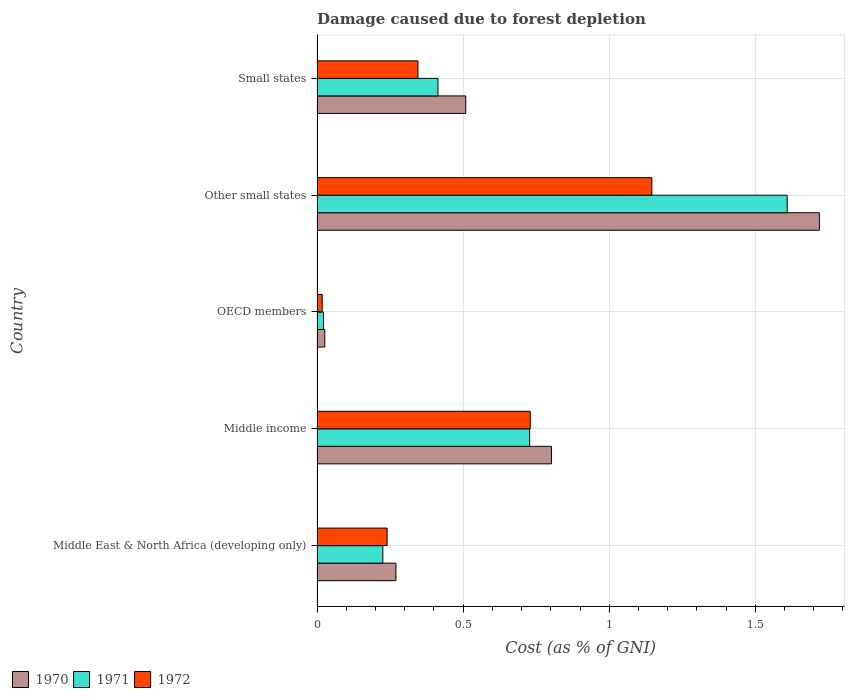How many groups of bars are there?
Keep it short and to the point. 5. Are the number of bars per tick equal to the number of legend labels?
Provide a short and direct response. Yes. How many bars are there on the 4th tick from the bottom?
Your answer should be very brief. 3. What is the label of the 2nd group of bars from the top?
Keep it short and to the point. Other small states. In how many cases, is the number of bars for a given country not equal to the number of legend labels?
Give a very brief answer. 0. What is the cost of damage caused due to forest depletion in 1971 in OECD members?
Offer a terse response. 0.02. Across all countries, what is the maximum cost of damage caused due to forest depletion in 1970?
Keep it short and to the point. 1.72. Across all countries, what is the minimum cost of damage caused due to forest depletion in 1971?
Ensure brevity in your answer.  0.02. In which country was the cost of damage caused due to forest depletion in 1970 maximum?
Provide a short and direct response. Other small states. What is the total cost of damage caused due to forest depletion in 1970 in the graph?
Provide a short and direct response. 3.33. What is the difference between the cost of damage caused due to forest depletion in 1970 in Middle East & North Africa (developing only) and that in Small states?
Your response must be concise. -0.24. What is the difference between the cost of damage caused due to forest depletion in 1970 in Middle income and the cost of damage caused due to forest depletion in 1972 in Small states?
Keep it short and to the point. 0.46. What is the average cost of damage caused due to forest depletion in 1971 per country?
Keep it short and to the point. 0.6. What is the difference between the cost of damage caused due to forest depletion in 1970 and cost of damage caused due to forest depletion in 1972 in Middle income?
Provide a short and direct response. 0.07. In how many countries, is the cost of damage caused due to forest depletion in 1970 greater than 0.9 %?
Keep it short and to the point. 1. What is the ratio of the cost of damage caused due to forest depletion in 1970 in Middle East & North Africa (developing only) to that in Middle income?
Make the answer very short. 0.34. What is the difference between the highest and the second highest cost of damage caused due to forest depletion in 1971?
Your response must be concise. 0.88. What is the difference between the highest and the lowest cost of damage caused due to forest depletion in 1972?
Your answer should be compact. 1.13. What does the 2nd bar from the bottom in Other small states represents?
Give a very brief answer. 1971. Is it the case that in every country, the sum of the cost of damage caused due to forest depletion in 1970 and cost of damage caused due to forest depletion in 1972 is greater than the cost of damage caused due to forest depletion in 1971?
Offer a terse response. Yes. How many countries are there in the graph?
Give a very brief answer. 5. Does the graph contain grids?
Give a very brief answer. Yes. Where does the legend appear in the graph?
Your answer should be compact. Bottom left. How are the legend labels stacked?
Offer a very short reply. Horizontal. What is the title of the graph?
Provide a short and direct response. Damage caused due to forest depletion. What is the label or title of the X-axis?
Make the answer very short. Cost (as % of GNI). What is the label or title of the Y-axis?
Provide a succinct answer. Country. What is the Cost (as % of GNI) in 1970 in Middle East & North Africa (developing only)?
Offer a very short reply. 0.27. What is the Cost (as % of GNI) of 1971 in Middle East & North Africa (developing only)?
Ensure brevity in your answer.  0.23. What is the Cost (as % of GNI) of 1972 in Middle East & North Africa (developing only)?
Your answer should be very brief. 0.24. What is the Cost (as % of GNI) of 1970 in Middle income?
Your answer should be compact. 0.8. What is the Cost (as % of GNI) in 1971 in Middle income?
Provide a short and direct response. 0.73. What is the Cost (as % of GNI) of 1972 in Middle income?
Your answer should be compact. 0.73. What is the Cost (as % of GNI) of 1970 in OECD members?
Give a very brief answer. 0.03. What is the Cost (as % of GNI) of 1971 in OECD members?
Offer a terse response. 0.02. What is the Cost (as % of GNI) of 1972 in OECD members?
Offer a very short reply. 0.02. What is the Cost (as % of GNI) in 1970 in Other small states?
Offer a very short reply. 1.72. What is the Cost (as % of GNI) in 1971 in Other small states?
Make the answer very short. 1.61. What is the Cost (as % of GNI) of 1972 in Other small states?
Your answer should be very brief. 1.15. What is the Cost (as % of GNI) of 1970 in Small states?
Your answer should be very brief. 0.51. What is the Cost (as % of GNI) in 1971 in Small states?
Keep it short and to the point. 0.41. What is the Cost (as % of GNI) of 1972 in Small states?
Ensure brevity in your answer.  0.35. Across all countries, what is the maximum Cost (as % of GNI) in 1970?
Provide a succinct answer. 1.72. Across all countries, what is the maximum Cost (as % of GNI) of 1971?
Give a very brief answer. 1.61. Across all countries, what is the maximum Cost (as % of GNI) of 1972?
Your response must be concise. 1.15. Across all countries, what is the minimum Cost (as % of GNI) in 1970?
Keep it short and to the point. 0.03. Across all countries, what is the minimum Cost (as % of GNI) of 1971?
Make the answer very short. 0.02. Across all countries, what is the minimum Cost (as % of GNI) in 1972?
Your answer should be compact. 0.02. What is the total Cost (as % of GNI) of 1970 in the graph?
Give a very brief answer. 3.33. What is the total Cost (as % of GNI) of 1971 in the graph?
Your answer should be compact. 3. What is the total Cost (as % of GNI) in 1972 in the graph?
Offer a very short reply. 2.48. What is the difference between the Cost (as % of GNI) in 1970 in Middle East & North Africa (developing only) and that in Middle income?
Your answer should be very brief. -0.53. What is the difference between the Cost (as % of GNI) in 1971 in Middle East & North Africa (developing only) and that in Middle income?
Ensure brevity in your answer.  -0.5. What is the difference between the Cost (as % of GNI) in 1972 in Middle East & North Africa (developing only) and that in Middle income?
Provide a short and direct response. -0.49. What is the difference between the Cost (as % of GNI) in 1970 in Middle East & North Africa (developing only) and that in OECD members?
Offer a very short reply. 0.24. What is the difference between the Cost (as % of GNI) in 1971 in Middle East & North Africa (developing only) and that in OECD members?
Ensure brevity in your answer.  0.2. What is the difference between the Cost (as % of GNI) of 1972 in Middle East & North Africa (developing only) and that in OECD members?
Offer a terse response. 0.22. What is the difference between the Cost (as % of GNI) in 1970 in Middle East & North Africa (developing only) and that in Other small states?
Ensure brevity in your answer.  -1.45. What is the difference between the Cost (as % of GNI) in 1971 in Middle East & North Africa (developing only) and that in Other small states?
Your answer should be compact. -1.38. What is the difference between the Cost (as % of GNI) of 1972 in Middle East & North Africa (developing only) and that in Other small states?
Your response must be concise. -0.91. What is the difference between the Cost (as % of GNI) of 1970 in Middle East & North Africa (developing only) and that in Small states?
Make the answer very short. -0.24. What is the difference between the Cost (as % of GNI) of 1971 in Middle East & North Africa (developing only) and that in Small states?
Your response must be concise. -0.19. What is the difference between the Cost (as % of GNI) of 1972 in Middle East & North Africa (developing only) and that in Small states?
Your answer should be compact. -0.11. What is the difference between the Cost (as % of GNI) of 1970 in Middle income and that in OECD members?
Offer a very short reply. 0.78. What is the difference between the Cost (as % of GNI) in 1971 in Middle income and that in OECD members?
Provide a succinct answer. 0.71. What is the difference between the Cost (as % of GNI) in 1972 in Middle income and that in OECD members?
Keep it short and to the point. 0.71. What is the difference between the Cost (as % of GNI) of 1970 in Middle income and that in Other small states?
Make the answer very short. -0.92. What is the difference between the Cost (as % of GNI) of 1971 in Middle income and that in Other small states?
Give a very brief answer. -0.88. What is the difference between the Cost (as % of GNI) in 1972 in Middle income and that in Other small states?
Your answer should be compact. -0.42. What is the difference between the Cost (as % of GNI) of 1970 in Middle income and that in Small states?
Keep it short and to the point. 0.29. What is the difference between the Cost (as % of GNI) in 1971 in Middle income and that in Small states?
Your answer should be compact. 0.31. What is the difference between the Cost (as % of GNI) in 1972 in Middle income and that in Small states?
Offer a terse response. 0.38. What is the difference between the Cost (as % of GNI) of 1970 in OECD members and that in Other small states?
Your response must be concise. -1.69. What is the difference between the Cost (as % of GNI) in 1971 in OECD members and that in Other small states?
Offer a very short reply. -1.59. What is the difference between the Cost (as % of GNI) of 1972 in OECD members and that in Other small states?
Ensure brevity in your answer.  -1.13. What is the difference between the Cost (as % of GNI) in 1970 in OECD members and that in Small states?
Offer a terse response. -0.48. What is the difference between the Cost (as % of GNI) of 1971 in OECD members and that in Small states?
Provide a succinct answer. -0.39. What is the difference between the Cost (as % of GNI) of 1972 in OECD members and that in Small states?
Offer a very short reply. -0.33. What is the difference between the Cost (as % of GNI) of 1970 in Other small states and that in Small states?
Ensure brevity in your answer.  1.21. What is the difference between the Cost (as % of GNI) of 1971 in Other small states and that in Small states?
Your response must be concise. 1.2. What is the difference between the Cost (as % of GNI) of 1972 in Other small states and that in Small states?
Your response must be concise. 0.8. What is the difference between the Cost (as % of GNI) of 1970 in Middle East & North Africa (developing only) and the Cost (as % of GNI) of 1971 in Middle income?
Keep it short and to the point. -0.46. What is the difference between the Cost (as % of GNI) of 1970 in Middle East & North Africa (developing only) and the Cost (as % of GNI) of 1972 in Middle income?
Give a very brief answer. -0.46. What is the difference between the Cost (as % of GNI) in 1971 in Middle East & North Africa (developing only) and the Cost (as % of GNI) in 1972 in Middle income?
Your response must be concise. -0.5. What is the difference between the Cost (as % of GNI) in 1970 in Middle East & North Africa (developing only) and the Cost (as % of GNI) in 1971 in OECD members?
Ensure brevity in your answer.  0.25. What is the difference between the Cost (as % of GNI) in 1970 in Middle East & North Africa (developing only) and the Cost (as % of GNI) in 1972 in OECD members?
Provide a succinct answer. 0.25. What is the difference between the Cost (as % of GNI) in 1971 in Middle East & North Africa (developing only) and the Cost (as % of GNI) in 1972 in OECD members?
Ensure brevity in your answer.  0.21. What is the difference between the Cost (as % of GNI) in 1970 in Middle East & North Africa (developing only) and the Cost (as % of GNI) in 1971 in Other small states?
Ensure brevity in your answer.  -1.34. What is the difference between the Cost (as % of GNI) of 1970 in Middle East & North Africa (developing only) and the Cost (as % of GNI) of 1972 in Other small states?
Your answer should be very brief. -0.88. What is the difference between the Cost (as % of GNI) in 1971 in Middle East & North Africa (developing only) and the Cost (as % of GNI) in 1972 in Other small states?
Provide a succinct answer. -0.92. What is the difference between the Cost (as % of GNI) of 1970 in Middle East & North Africa (developing only) and the Cost (as % of GNI) of 1971 in Small states?
Your answer should be compact. -0.14. What is the difference between the Cost (as % of GNI) of 1970 in Middle East & North Africa (developing only) and the Cost (as % of GNI) of 1972 in Small states?
Provide a succinct answer. -0.08. What is the difference between the Cost (as % of GNI) of 1971 in Middle East & North Africa (developing only) and the Cost (as % of GNI) of 1972 in Small states?
Offer a terse response. -0.12. What is the difference between the Cost (as % of GNI) of 1970 in Middle income and the Cost (as % of GNI) of 1971 in OECD members?
Offer a terse response. 0.78. What is the difference between the Cost (as % of GNI) in 1970 in Middle income and the Cost (as % of GNI) in 1972 in OECD members?
Ensure brevity in your answer.  0.78. What is the difference between the Cost (as % of GNI) of 1971 in Middle income and the Cost (as % of GNI) of 1972 in OECD members?
Make the answer very short. 0.71. What is the difference between the Cost (as % of GNI) of 1970 in Middle income and the Cost (as % of GNI) of 1971 in Other small states?
Offer a very short reply. -0.81. What is the difference between the Cost (as % of GNI) of 1970 in Middle income and the Cost (as % of GNI) of 1972 in Other small states?
Your answer should be very brief. -0.34. What is the difference between the Cost (as % of GNI) in 1971 in Middle income and the Cost (as % of GNI) in 1972 in Other small states?
Offer a very short reply. -0.42. What is the difference between the Cost (as % of GNI) of 1970 in Middle income and the Cost (as % of GNI) of 1971 in Small states?
Keep it short and to the point. 0.39. What is the difference between the Cost (as % of GNI) of 1970 in Middle income and the Cost (as % of GNI) of 1972 in Small states?
Keep it short and to the point. 0.46. What is the difference between the Cost (as % of GNI) of 1971 in Middle income and the Cost (as % of GNI) of 1972 in Small states?
Provide a short and direct response. 0.38. What is the difference between the Cost (as % of GNI) of 1970 in OECD members and the Cost (as % of GNI) of 1971 in Other small states?
Give a very brief answer. -1.58. What is the difference between the Cost (as % of GNI) of 1970 in OECD members and the Cost (as % of GNI) of 1972 in Other small states?
Give a very brief answer. -1.12. What is the difference between the Cost (as % of GNI) in 1971 in OECD members and the Cost (as % of GNI) in 1972 in Other small states?
Make the answer very short. -1.12. What is the difference between the Cost (as % of GNI) of 1970 in OECD members and the Cost (as % of GNI) of 1971 in Small states?
Provide a succinct answer. -0.39. What is the difference between the Cost (as % of GNI) in 1970 in OECD members and the Cost (as % of GNI) in 1972 in Small states?
Your answer should be compact. -0.32. What is the difference between the Cost (as % of GNI) in 1971 in OECD members and the Cost (as % of GNI) in 1972 in Small states?
Your response must be concise. -0.32. What is the difference between the Cost (as % of GNI) in 1970 in Other small states and the Cost (as % of GNI) in 1971 in Small states?
Give a very brief answer. 1.31. What is the difference between the Cost (as % of GNI) in 1970 in Other small states and the Cost (as % of GNI) in 1972 in Small states?
Your answer should be compact. 1.37. What is the difference between the Cost (as % of GNI) in 1971 in Other small states and the Cost (as % of GNI) in 1972 in Small states?
Make the answer very short. 1.26. What is the average Cost (as % of GNI) in 1970 per country?
Give a very brief answer. 0.67. What is the average Cost (as % of GNI) of 1971 per country?
Make the answer very short. 0.6. What is the average Cost (as % of GNI) in 1972 per country?
Your answer should be compact. 0.5. What is the difference between the Cost (as % of GNI) in 1970 and Cost (as % of GNI) in 1971 in Middle East & North Africa (developing only)?
Offer a very short reply. 0.04. What is the difference between the Cost (as % of GNI) of 1970 and Cost (as % of GNI) of 1972 in Middle East & North Africa (developing only)?
Keep it short and to the point. 0.03. What is the difference between the Cost (as % of GNI) of 1971 and Cost (as % of GNI) of 1972 in Middle East & North Africa (developing only)?
Provide a short and direct response. -0.01. What is the difference between the Cost (as % of GNI) in 1970 and Cost (as % of GNI) in 1971 in Middle income?
Your answer should be compact. 0.07. What is the difference between the Cost (as % of GNI) of 1970 and Cost (as % of GNI) of 1972 in Middle income?
Make the answer very short. 0.07. What is the difference between the Cost (as % of GNI) in 1971 and Cost (as % of GNI) in 1972 in Middle income?
Provide a short and direct response. -0. What is the difference between the Cost (as % of GNI) in 1970 and Cost (as % of GNI) in 1971 in OECD members?
Your answer should be very brief. 0. What is the difference between the Cost (as % of GNI) of 1970 and Cost (as % of GNI) of 1972 in OECD members?
Provide a succinct answer. 0.01. What is the difference between the Cost (as % of GNI) of 1971 and Cost (as % of GNI) of 1972 in OECD members?
Keep it short and to the point. 0. What is the difference between the Cost (as % of GNI) in 1970 and Cost (as % of GNI) in 1971 in Other small states?
Ensure brevity in your answer.  0.11. What is the difference between the Cost (as % of GNI) of 1970 and Cost (as % of GNI) of 1972 in Other small states?
Provide a short and direct response. 0.57. What is the difference between the Cost (as % of GNI) of 1971 and Cost (as % of GNI) of 1972 in Other small states?
Give a very brief answer. 0.46. What is the difference between the Cost (as % of GNI) in 1970 and Cost (as % of GNI) in 1971 in Small states?
Your response must be concise. 0.1. What is the difference between the Cost (as % of GNI) of 1970 and Cost (as % of GNI) of 1972 in Small states?
Offer a very short reply. 0.16. What is the difference between the Cost (as % of GNI) of 1971 and Cost (as % of GNI) of 1972 in Small states?
Your answer should be compact. 0.07. What is the ratio of the Cost (as % of GNI) in 1970 in Middle East & North Africa (developing only) to that in Middle income?
Provide a short and direct response. 0.34. What is the ratio of the Cost (as % of GNI) in 1971 in Middle East & North Africa (developing only) to that in Middle income?
Keep it short and to the point. 0.31. What is the ratio of the Cost (as % of GNI) in 1972 in Middle East & North Africa (developing only) to that in Middle income?
Your response must be concise. 0.33. What is the ratio of the Cost (as % of GNI) in 1970 in Middle East & North Africa (developing only) to that in OECD members?
Provide a succinct answer. 10.19. What is the ratio of the Cost (as % of GNI) of 1971 in Middle East & North Africa (developing only) to that in OECD members?
Ensure brevity in your answer.  10.12. What is the ratio of the Cost (as % of GNI) of 1972 in Middle East & North Africa (developing only) to that in OECD members?
Give a very brief answer. 13.63. What is the ratio of the Cost (as % of GNI) in 1970 in Middle East & North Africa (developing only) to that in Other small states?
Keep it short and to the point. 0.16. What is the ratio of the Cost (as % of GNI) in 1971 in Middle East & North Africa (developing only) to that in Other small states?
Provide a succinct answer. 0.14. What is the ratio of the Cost (as % of GNI) in 1972 in Middle East & North Africa (developing only) to that in Other small states?
Provide a succinct answer. 0.21. What is the ratio of the Cost (as % of GNI) in 1970 in Middle East & North Africa (developing only) to that in Small states?
Provide a succinct answer. 0.53. What is the ratio of the Cost (as % of GNI) in 1971 in Middle East & North Africa (developing only) to that in Small states?
Provide a succinct answer. 0.54. What is the ratio of the Cost (as % of GNI) of 1972 in Middle East & North Africa (developing only) to that in Small states?
Offer a very short reply. 0.69. What is the ratio of the Cost (as % of GNI) of 1970 in Middle income to that in OECD members?
Your answer should be very brief. 30.28. What is the ratio of the Cost (as % of GNI) in 1971 in Middle income to that in OECD members?
Your answer should be compact. 32.71. What is the ratio of the Cost (as % of GNI) of 1972 in Middle income to that in OECD members?
Your answer should be very brief. 41.48. What is the ratio of the Cost (as % of GNI) in 1970 in Middle income to that in Other small states?
Keep it short and to the point. 0.47. What is the ratio of the Cost (as % of GNI) in 1971 in Middle income to that in Other small states?
Provide a short and direct response. 0.45. What is the ratio of the Cost (as % of GNI) of 1972 in Middle income to that in Other small states?
Ensure brevity in your answer.  0.64. What is the ratio of the Cost (as % of GNI) in 1970 in Middle income to that in Small states?
Ensure brevity in your answer.  1.58. What is the ratio of the Cost (as % of GNI) in 1971 in Middle income to that in Small states?
Give a very brief answer. 1.76. What is the ratio of the Cost (as % of GNI) in 1972 in Middle income to that in Small states?
Provide a short and direct response. 2.11. What is the ratio of the Cost (as % of GNI) of 1970 in OECD members to that in Other small states?
Your answer should be very brief. 0.02. What is the ratio of the Cost (as % of GNI) of 1971 in OECD members to that in Other small states?
Provide a succinct answer. 0.01. What is the ratio of the Cost (as % of GNI) of 1972 in OECD members to that in Other small states?
Offer a very short reply. 0.02. What is the ratio of the Cost (as % of GNI) of 1970 in OECD members to that in Small states?
Make the answer very short. 0.05. What is the ratio of the Cost (as % of GNI) in 1971 in OECD members to that in Small states?
Ensure brevity in your answer.  0.05. What is the ratio of the Cost (as % of GNI) of 1972 in OECD members to that in Small states?
Offer a terse response. 0.05. What is the ratio of the Cost (as % of GNI) in 1970 in Other small states to that in Small states?
Give a very brief answer. 3.38. What is the ratio of the Cost (as % of GNI) in 1971 in Other small states to that in Small states?
Your response must be concise. 3.89. What is the ratio of the Cost (as % of GNI) in 1972 in Other small states to that in Small states?
Keep it short and to the point. 3.32. What is the difference between the highest and the second highest Cost (as % of GNI) of 1970?
Give a very brief answer. 0.92. What is the difference between the highest and the second highest Cost (as % of GNI) in 1971?
Offer a very short reply. 0.88. What is the difference between the highest and the second highest Cost (as % of GNI) of 1972?
Your answer should be very brief. 0.42. What is the difference between the highest and the lowest Cost (as % of GNI) in 1970?
Provide a short and direct response. 1.69. What is the difference between the highest and the lowest Cost (as % of GNI) in 1971?
Provide a succinct answer. 1.59. What is the difference between the highest and the lowest Cost (as % of GNI) in 1972?
Your answer should be compact. 1.13. 